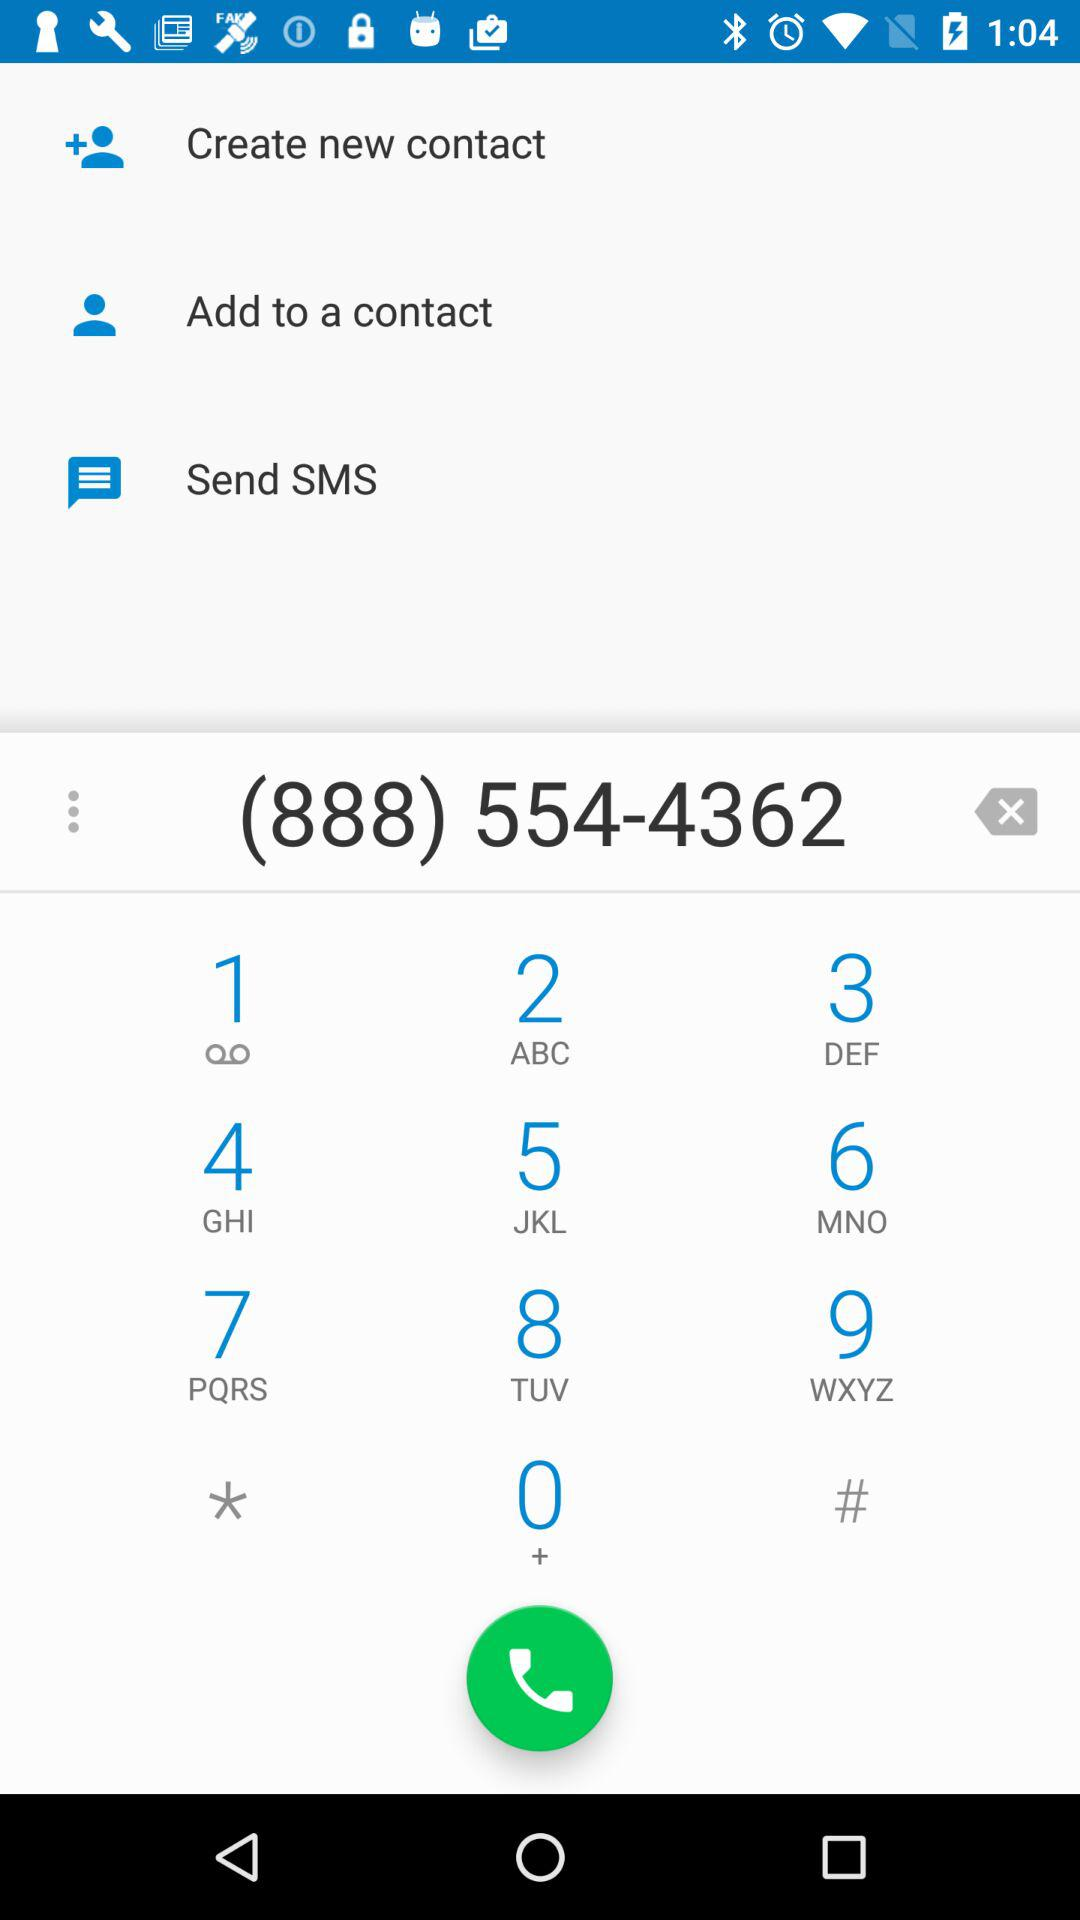Is this number added as a contact?
When the provided information is insufficient, respond with <no answer>. <no answer> 